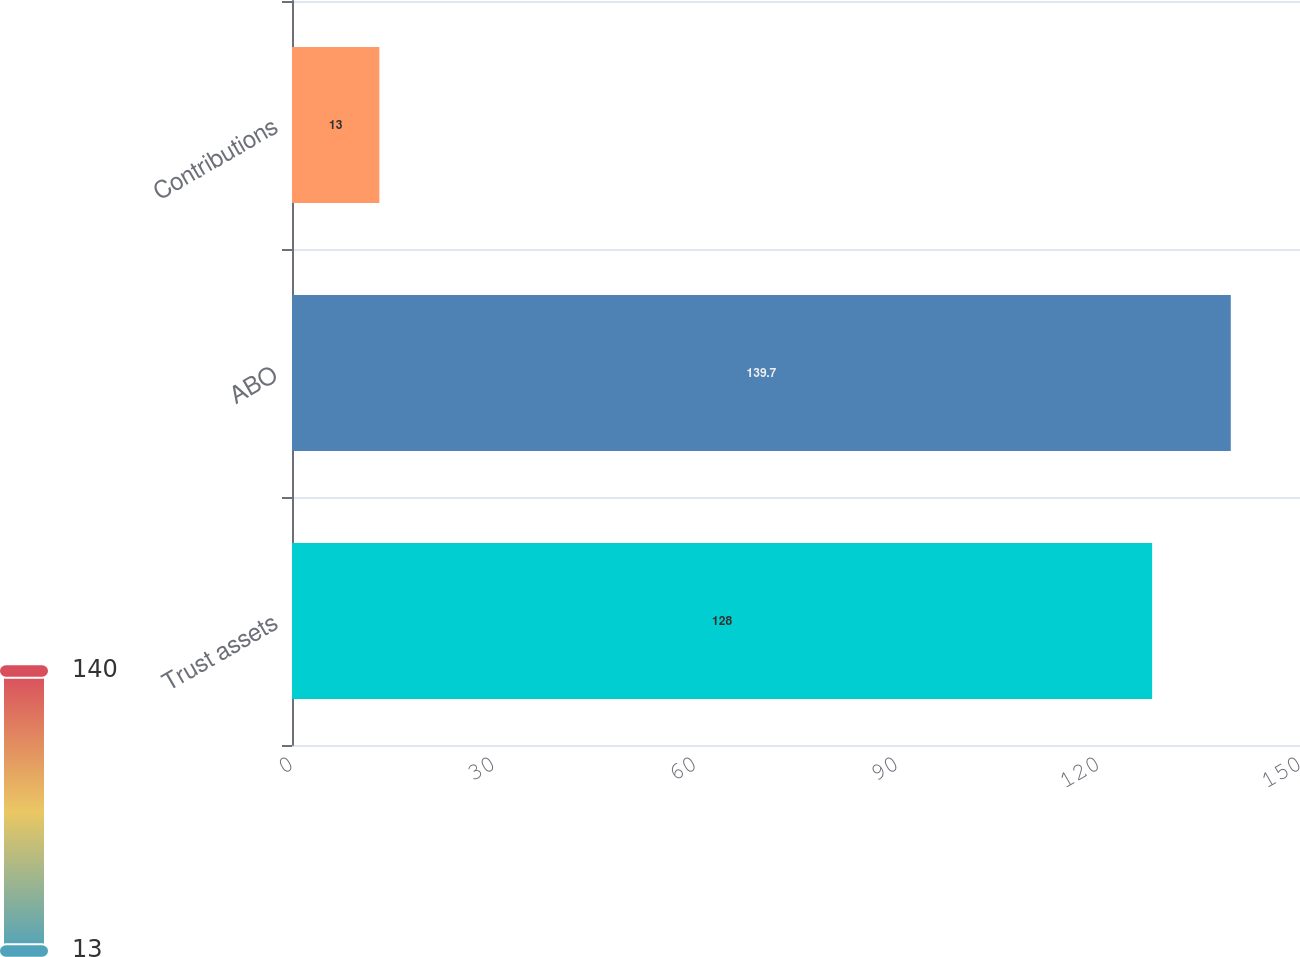Convert chart. <chart><loc_0><loc_0><loc_500><loc_500><bar_chart><fcel>Trust assets<fcel>ABO<fcel>Contributions<nl><fcel>128<fcel>139.7<fcel>13<nl></chart> 